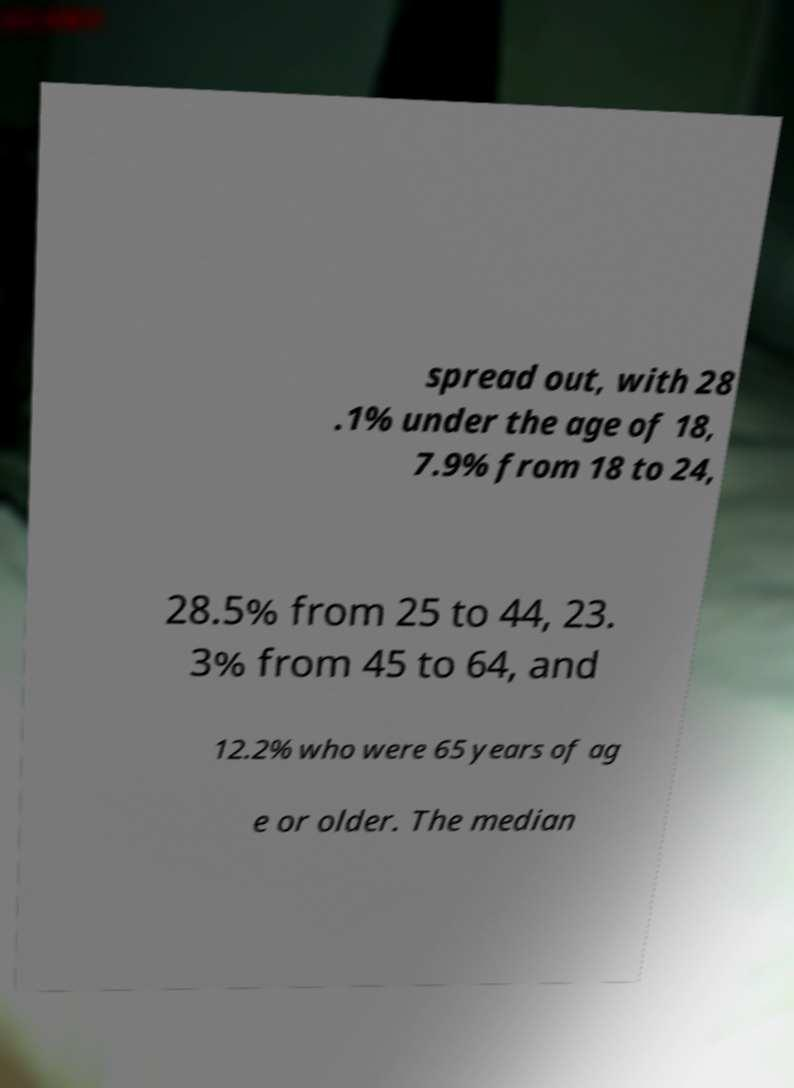There's text embedded in this image that I need extracted. Can you transcribe it verbatim? spread out, with 28 .1% under the age of 18, 7.9% from 18 to 24, 28.5% from 25 to 44, 23. 3% from 45 to 64, and 12.2% who were 65 years of ag e or older. The median 